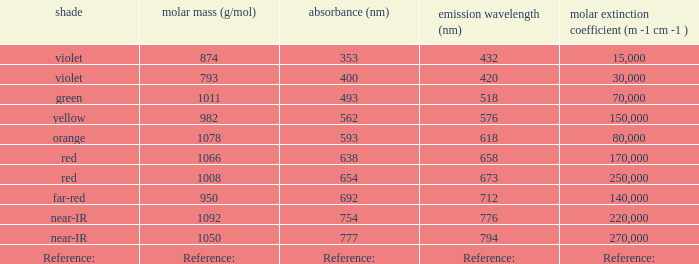What is the absorption (in nanometers) of violet color having a 432 nm emission? 353.0. 